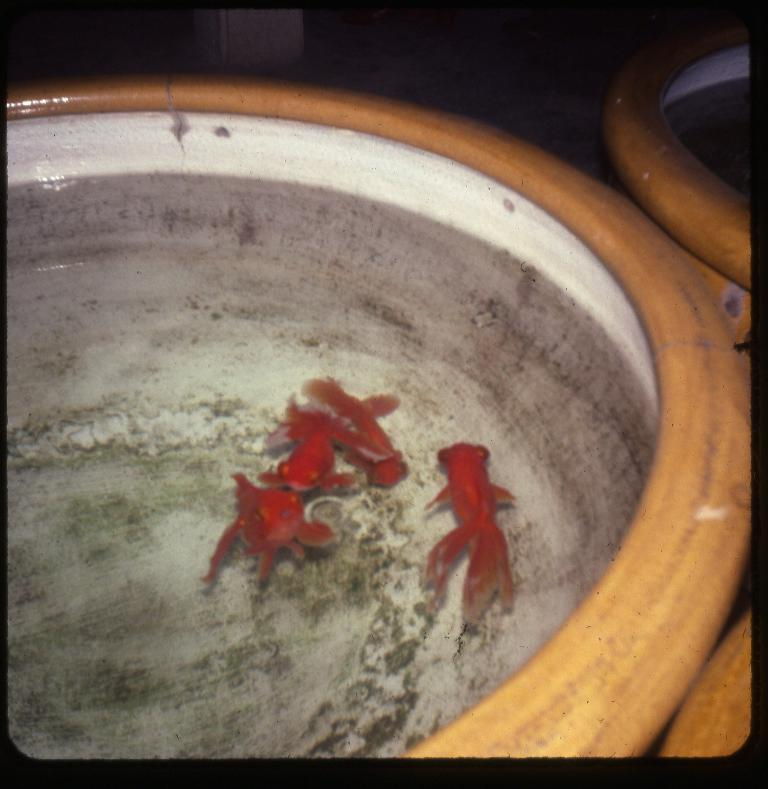What type of animals can be seen in the image? There are fishes in the image. Where are the fishes located? The fishes are swimming in a wooden pot. What type of bag is being used to carry the quill in the image? There is no bag or quill present in the image; it features fishes swimming in a wooden pot. 